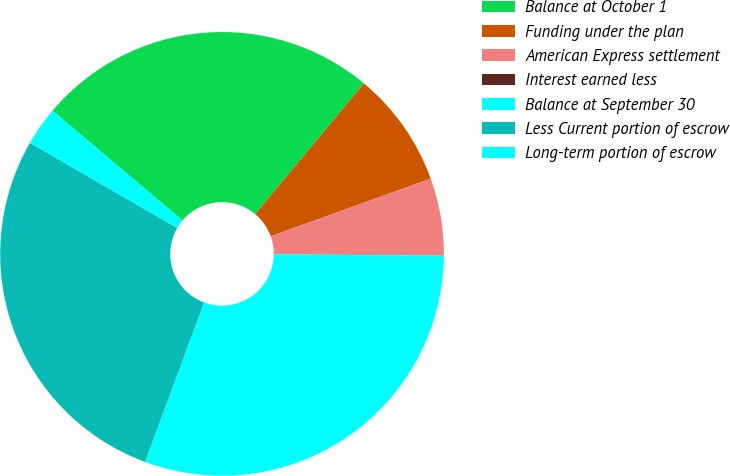<chart> <loc_0><loc_0><loc_500><loc_500><pie_chart><fcel>Balance at October 1<fcel>Funding under the plan<fcel>American Express settlement<fcel>Interest earned less<fcel>Balance at September 30<fcel>Less Current portion of escrow<fcel>Long-term portion of escrow<nl><fcel>24.89%<fcel>8.44%<fcel>5.63%<fcel>0.01%<fcel>30.51%<fcel>27.7%<fcel>2.82%<nl></chart> 